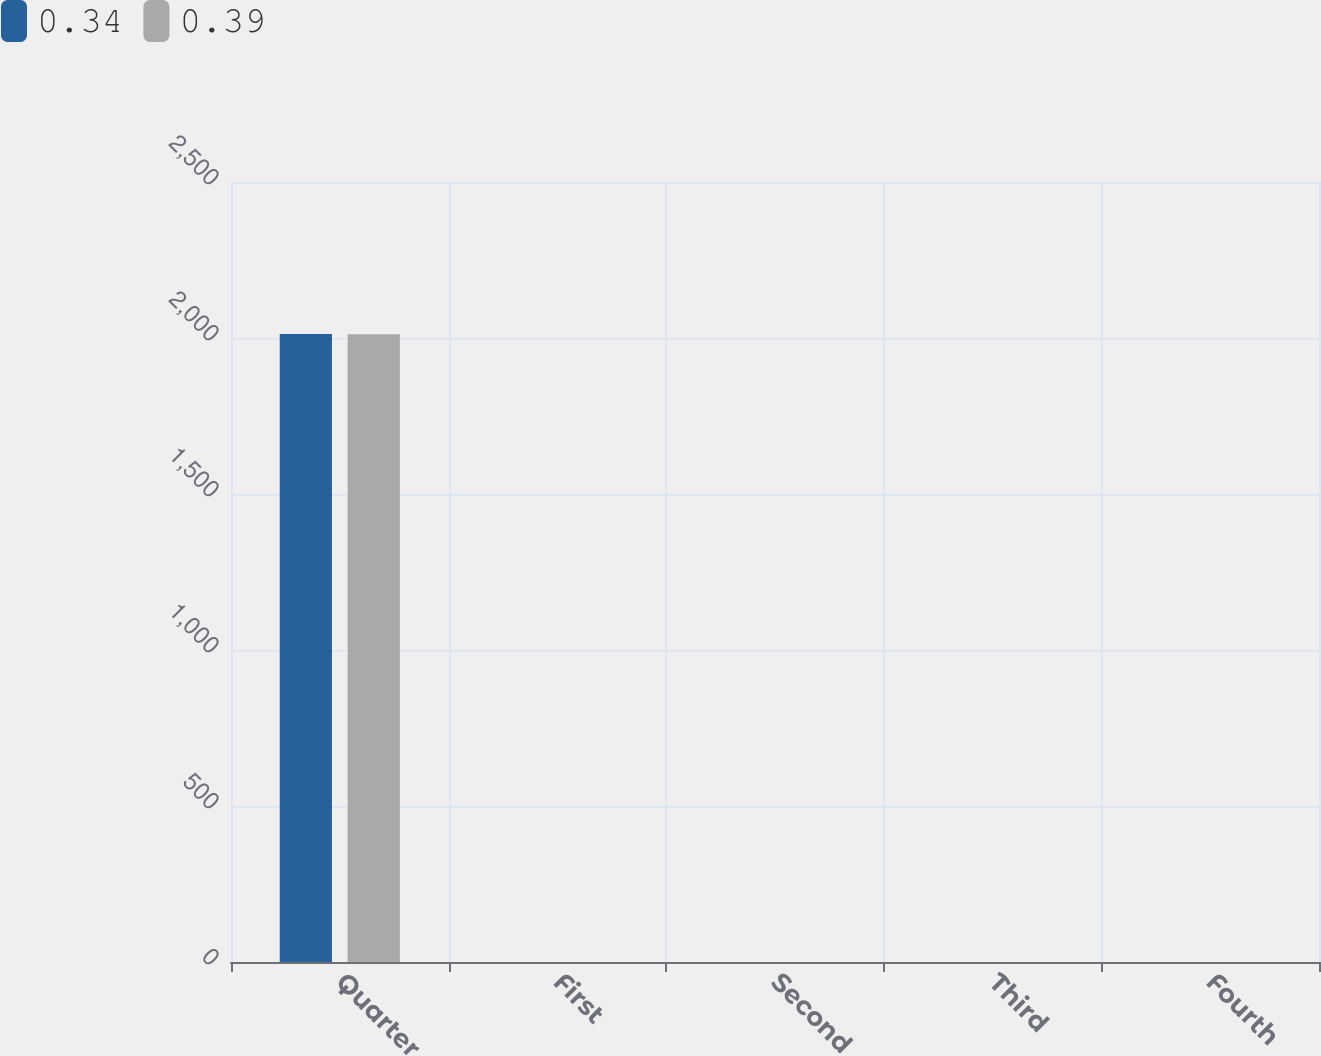Convert chart. <chart><loc_0><loc_0><loc_500><loc_500><stacked_bar_chart><ecel><fcel>Quarter<fcel>First<fcel>Second<fcel>Third<fcel>Fourth<nl><fcel>0.34<fcel>2013<fcel>0.34<fcel>0.34<fcel>0.39<fcel>0.39<nl><fcel>0.39<fcel>2012<fcel>0.31<fcel>0.31<fcel>0.34<fcel>0.34<nl></chart> 